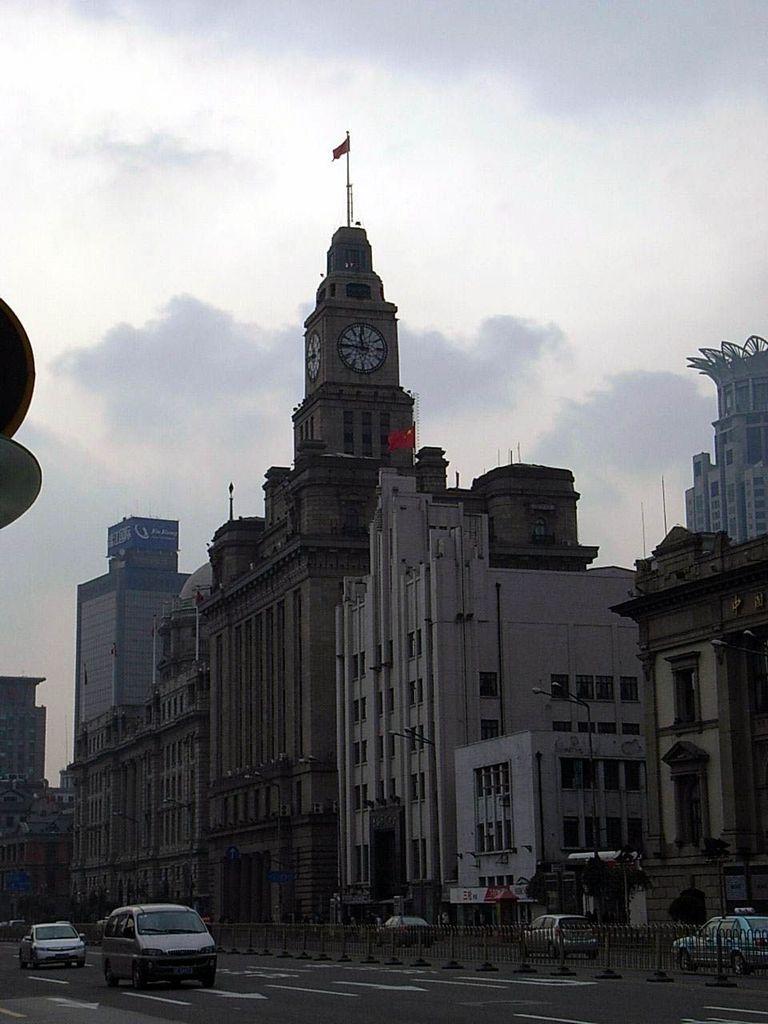How would you summarize this image in a sentence or two? In the center of the image there are buildings. At the top of the image there is sky. At the bottom of the image there is road. There are vehicles on the road. 